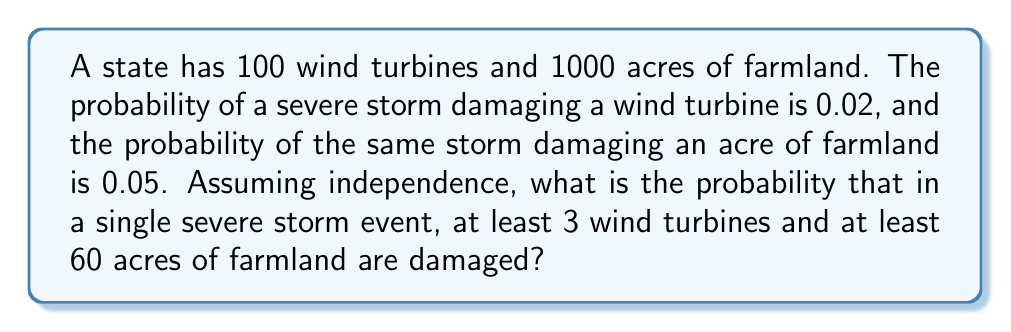Solve this math problem. Let's approach this step-by-step:

1) For wind turbines:
   - We need the probability of at least 3 turbines being damaged
   - This follows a binomial distribution: $X \sim B(100, 0.02)$
   - We want $P(X \geq 3) = 1 - P(X < 3) = 1 - [P(X=0) + P(X=1) + P(X=2)]$
   
   $$P(X \geq 3) = 1 - [\binom{100}{0}(0.02)^0(0.98)^{100} + \binom{100}{1}(0.02)^1(0.98)^{99} + \binom{100}{2}(0.02)^2(0.98)^{98}]$$

2) For farmland:
   - We need the probability of at least 60 acres being damaged
   - This follows a binomial distribution: $Y \sim B(1000, 0.05)$
   - We want $P(Y \geq 60)$
   - We can use the normal approximation to the binomial distribution since $np$ and $n(1-p)$ are both > 5
   - Mean: $\mu = np = 1000 * 0.05 = 50$
   - Standard deviation: $\sigma = \sqrt{np(1-p)} = \sqrt{1000 * 0.05 * 0.95} \approx 6.89$
   
   $$P(Y \geq 60) = P(Z \geq \frac{59.5 - 50}{6.89}) = P(Z \geq 1.38)$$

3) Using a standard normal table or calculator, we find:
   $P(Z \geq 1.38) \approx 0.0838$

4) Assuming independence, the probability of both events occurring is:

   $$P(\text{at least 3 turbines AND at least 60 acres}) = P(X \geq 3) * P(Y \geq 60)$$

5) Calculate $P(X \geq 3)$ using a calculator or computer:
   $P(X \geq 3) \approx 0.3233$

6) Final calculation:
   $0.3233 * 0.0838 \approx 0.0271$
Answer: 0.0271 